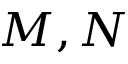Convert formula to latex. <formula><loc_0><loc_0><loc_500><loc_500>M , N</formula> 